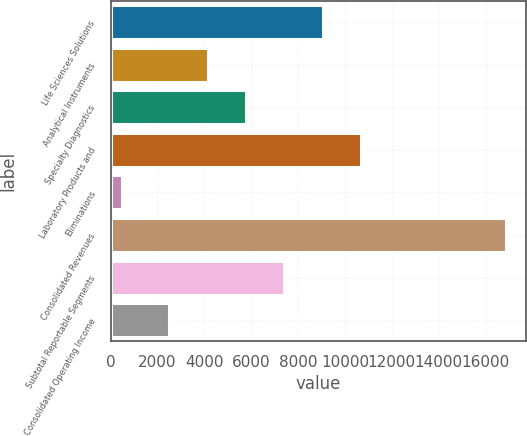Convert chart. <chart><loc_0><loc_0><loc_500><loc_500><bar_chart><fcel>Life Sciences Solutions<fcel>Analytical Instruments<fcel>Specialty Diagnostics<fcel>Laboratory Products and<fcel>Eliminations<fcel>Consolidated Revenues<fcel>Subtotal Reportable Segments<fcel>Consolidated Operating Income<nl><fcel>9057.48<fcel>4141.62<fcel>5780.24<fcel>10696.1<fcel>503.4<fcel>16889.6<fcel>7418.86<fcel>2503<nl></chart> 